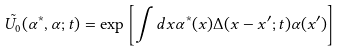Convert formula to latex. <formula><loc_0><loc_0><loc_500><loc_500>\tilde { U _ { 0 } } ( \alpha ^ { * } , \alpha ; t ) = \exp \left [ \int d x \alpha ^ { * } ( { x } ) \Delta ( { x } - { x } ^ { \prime } ; t ) \alpha ( { x } ^ { \prime } ) \right ]</formula> 